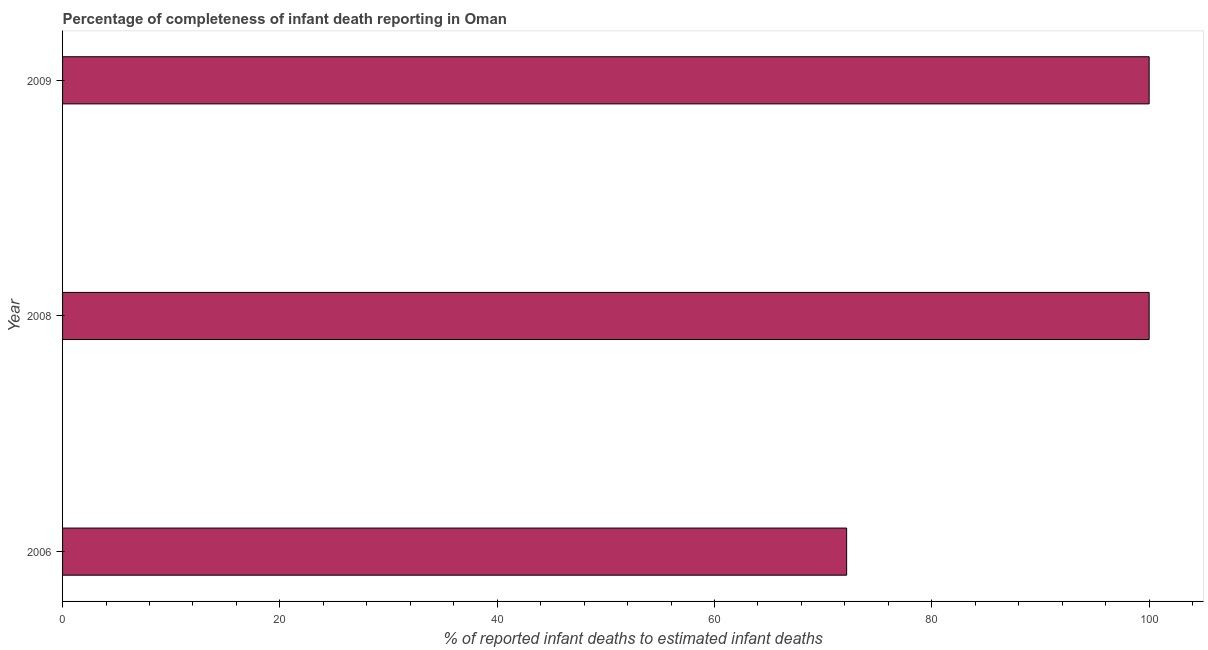Does the graph contain any zero values?
Provide a succinct answer. No. Does the graph contain grids?
Provide a succinct answer. No. What is the title of the graph?
Provide a succinct answer. Percentage of completeness of infant death reporting in Oman. What is the label or title of the X-axis?
Your response must be concise. % of reported infant deaths to estimated infant deaths. What is the completeness of infant death reporting in 2006?
Give a very brief answer. 72.16. Across all years, what is the minimum completeness of infant death reporting?
Offer a terse response. 72.16. What is the sum of the completeness of infant death reporting?
Ensure brevity in your answer.  272.16. What is the difference between the completeness of infant death reporting in 2006 and 2008?
Ensure brevity in your answer.  -27.84. What is the average completeness of infant death reporting per year?
Your response must be concise. 90.72. What is the median completeness of infant death reporting?
Give a very brief answer. 100. What is the ratio of the completeness of infant death reporting in 2006 to that in 2008?
Provide a succinct answer. 0.72. Is the completeness of infant death reporting in 2006 less than that in 2009?
Your answer should be compact. Yes. Is the sum of the completeness of infant death reporting in 2008 and 2009 greater than the maximum completeness of infant death reporting across all years?
Provide a short and direct response. Yes. What is the difference between the highest and the lowest completeness of infant death reporting?
Ensure brevity in your answer.  27.84. Are all the bars in the graph horizontal?
Make the answer very short. Yes. What is the % of reported infant deaths to estimated infant deaths of 2006?
Your answer should be very brief. 72.16. What is the % of reported infant deaths to estimated infant deaths of 2008?
Keep it short and to the point. 100. What is the % of reported infant deaths to estimated infant deaths of 2009?
Offer a terse response. 100. What is the difference between the % of reported infant deaths to estimated infant deaths in 2006 and 2008?
Provide a succinct answer. -27.84. What is the difference between the % of reported infant deaths to estimated infant deaths in 2006 and 2009?
Offer a terse response. -27.84. What is the difference between the % of reported infant deaths to estimated infant deaths in 2008 and 2009?
Your response must be concise. 0. What is the ratio of the % of reported infant deaths to estimated infant deaths in 2006 to that in 2008?
Offer a very short reply. 0.72. What is the ratio of the % of reported infant deaths to estimated infant deaths in 2006 to that in 2009?
Your answer should be very brief. 0.72. 